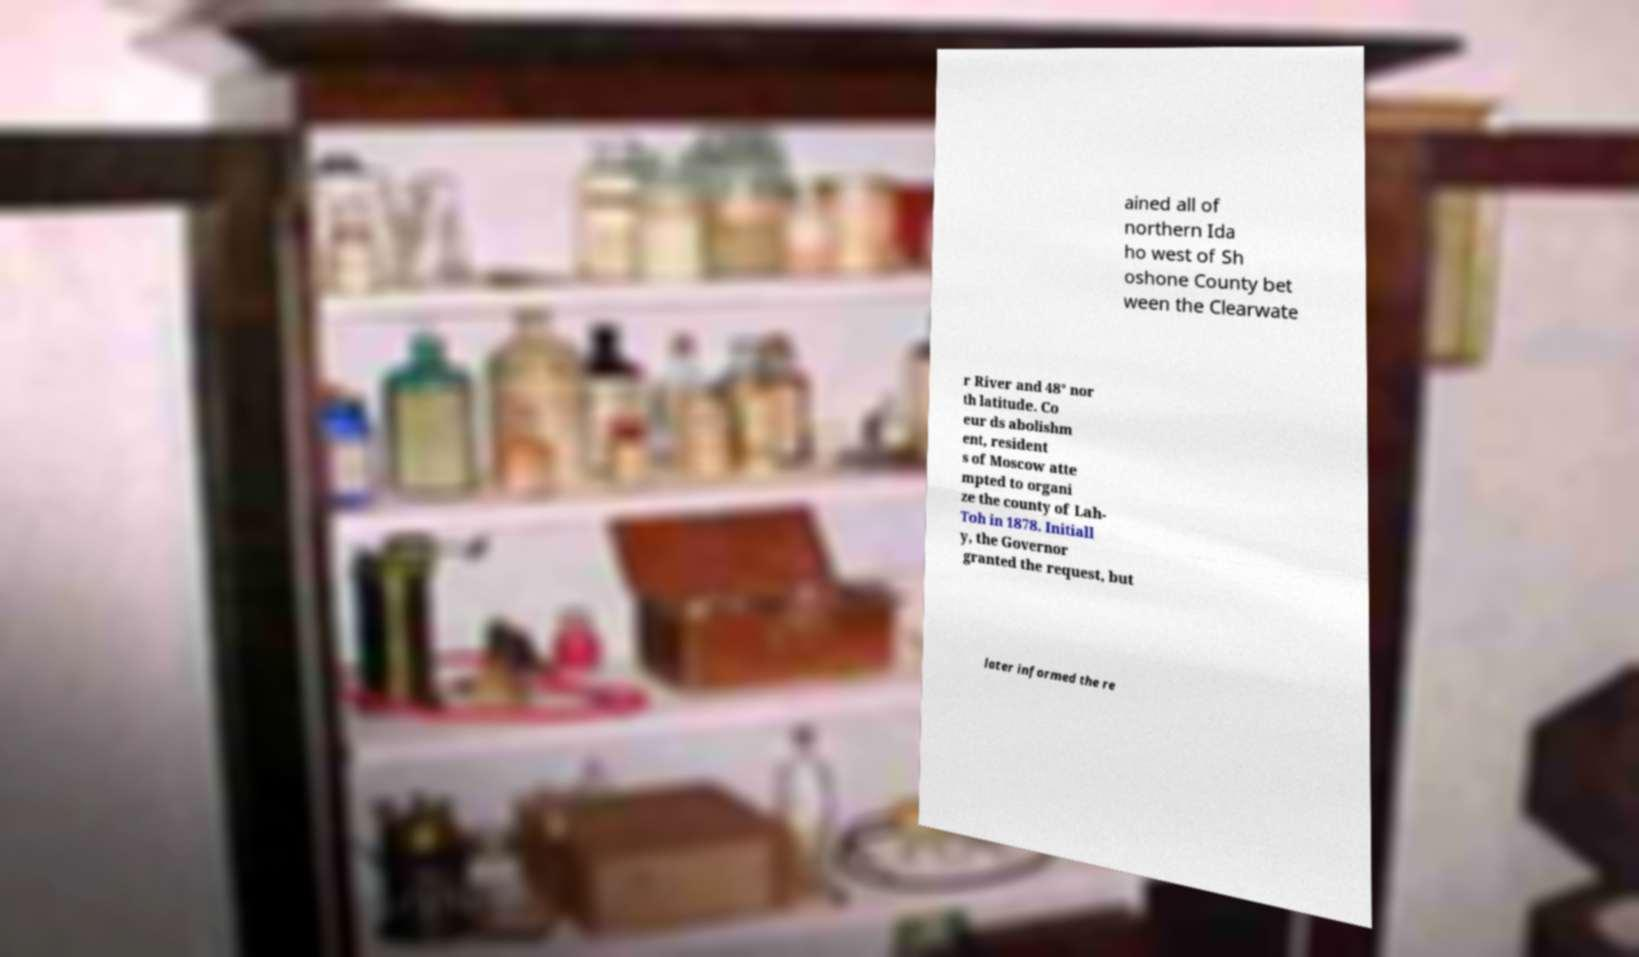Could you assist in decoding the text presented in this image and type it out clearly? ained all of northern Ida ho west of Sh oshone County bet ween the Clearwate r River and 48° nor th latitude. Co eur ds abolishm ent, resident s of Moscow atte mpted to organi ze the county of Lah- Toh in 1878. Initiall y, the Governor granted the request, but later informed the re 